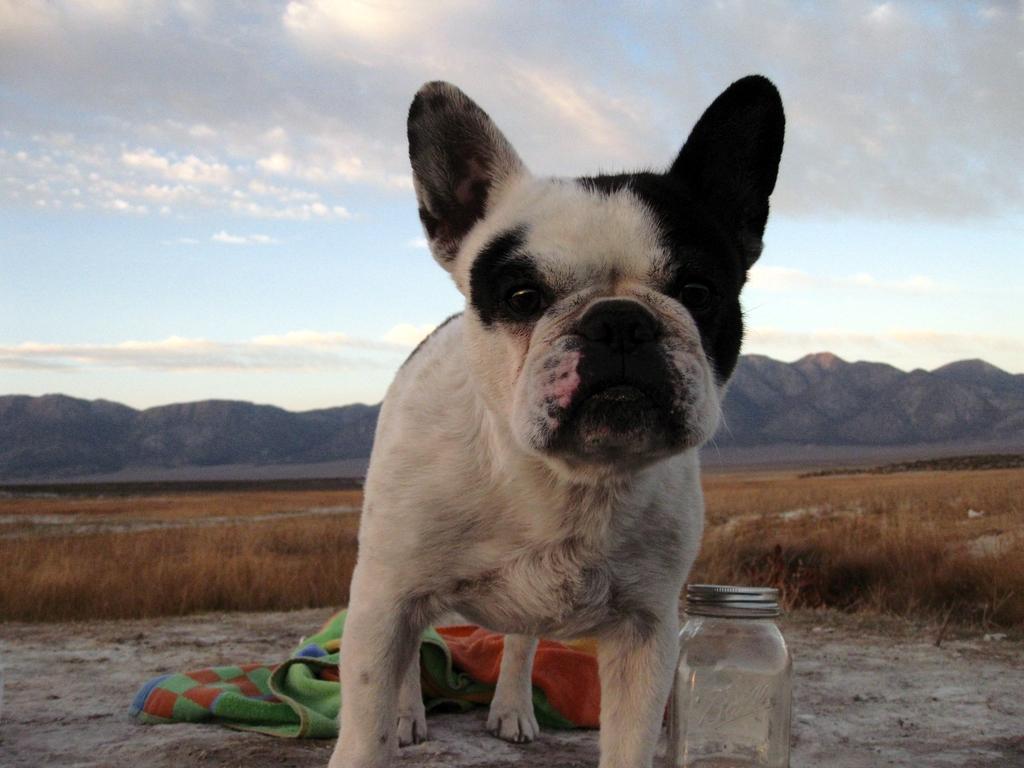Please provide a concise description of this image. In this image I can see a small puppy. Behind that puppy I can see a green color blanket and I can see a small jar with a lid which is closed. At background I can see hills,grass,sky with clouds. 